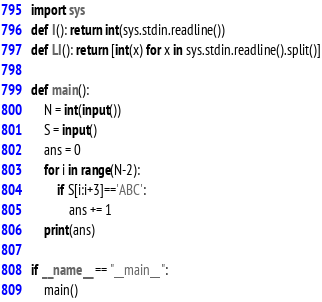<code> <loc_0><loc_0><loc_500><loc_500><_Python_>import sys
def I(): return int(sys.stdin.readline())
def LI(): return [int(x) for x in sys.stdin.readline().split()]

def main():
    N = int(input())
    S = input()
    ans = 0
    for i in range(N-2):
        if S[i:i+3]=='ABC':
            ans += 1
    print(ans)

if __name__ == "__main__":
    main()
</code> 